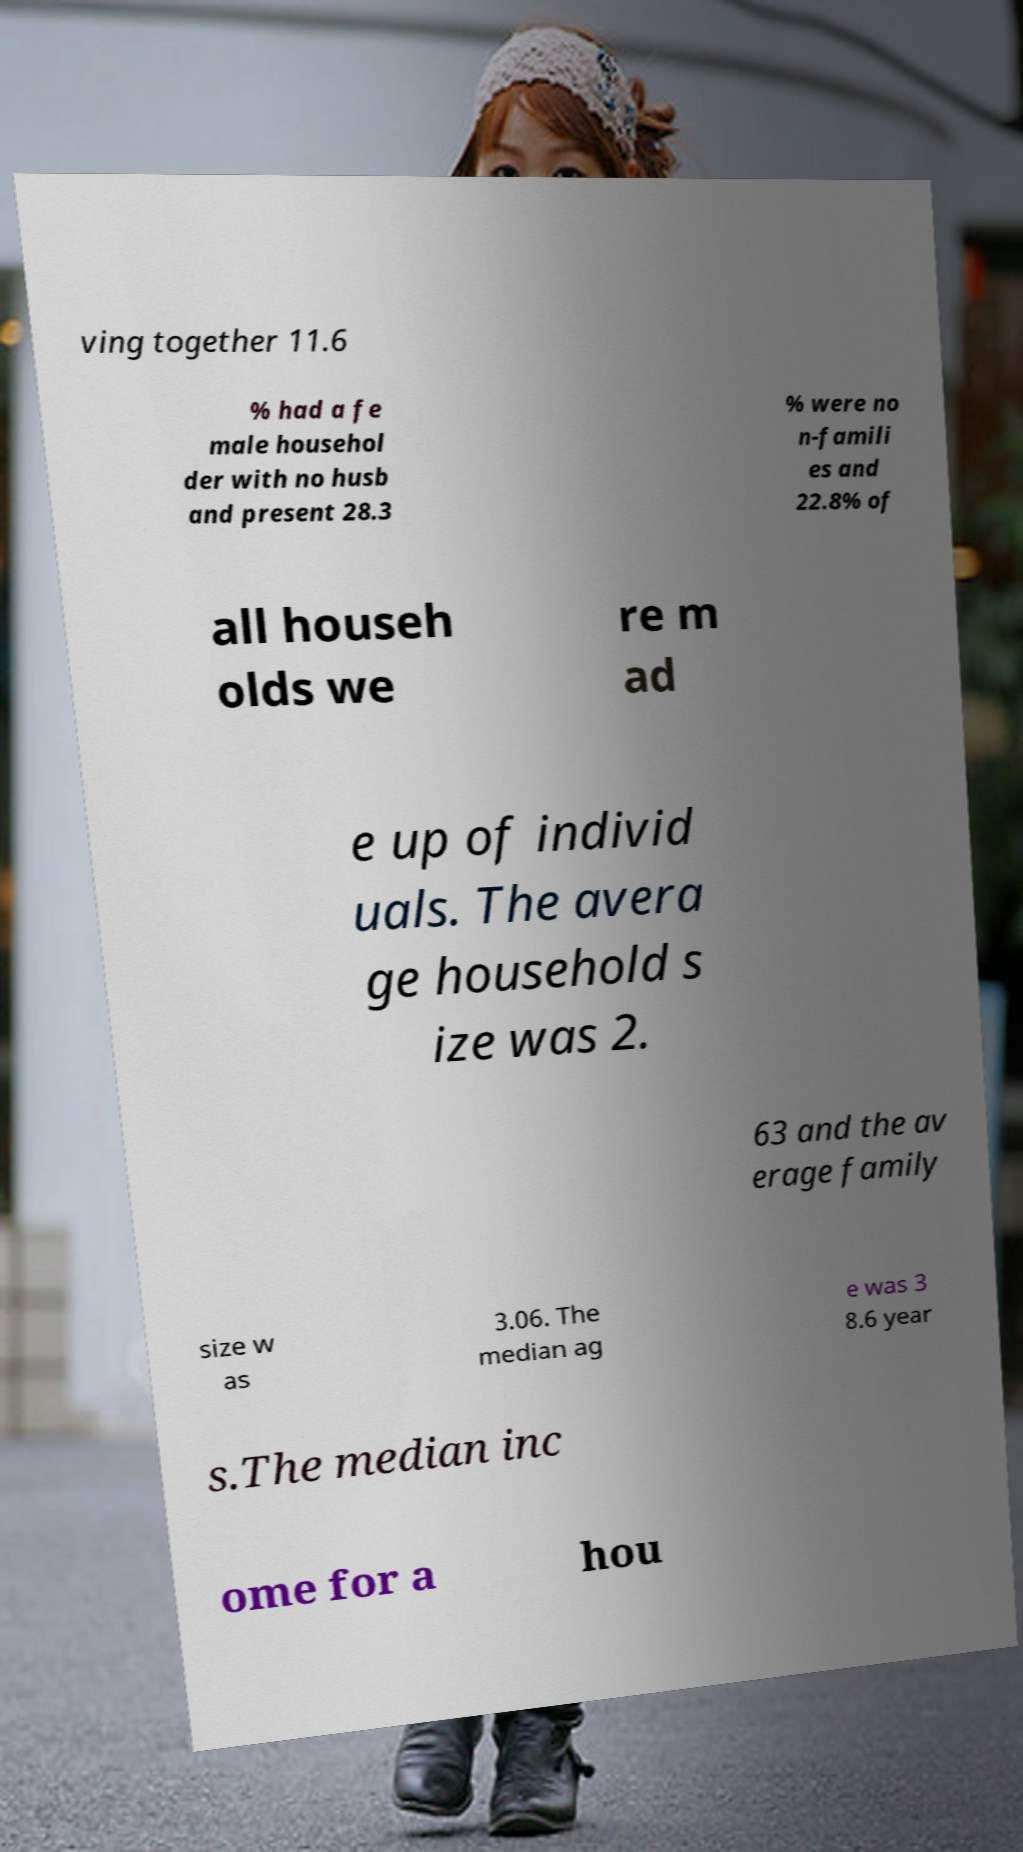Can you read and provide the text displayed in the image?This photo seems to have some interesting text. Can you extract and type it out for me? ving together 11.6 % had a fe male househol der with no husb and present 28.3 % were no n-famili es and 22.8% of all househ olds we re m ad e up of individ uals. The avera ge household s ize was 2. 63 and the av erage family size w as 3.06. The median ag e was 3 8.6 year s.The median inc ome for a hou 